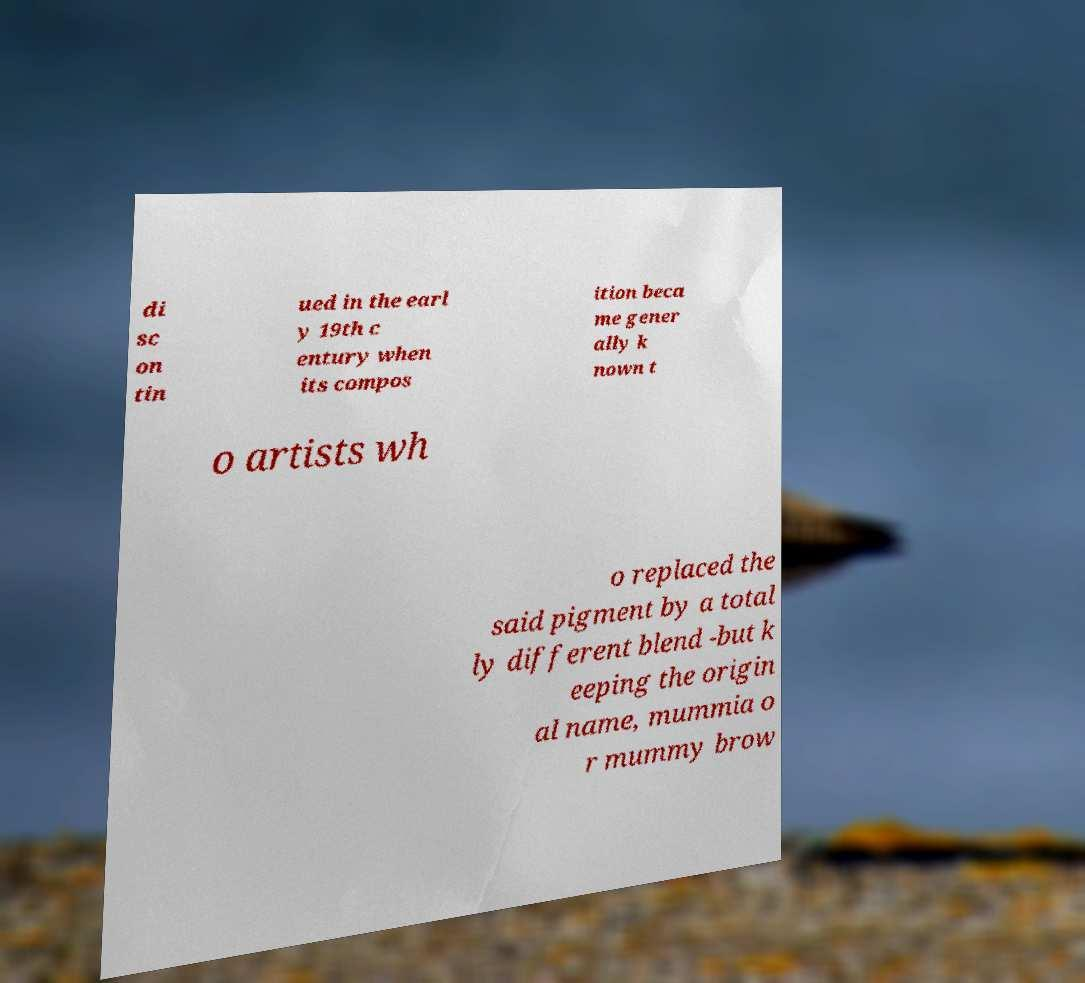For documentation purposes, I need the text within this image transcribed. Could you provide that? di sc on tin ued in the earl y 19th c entury when its compos ition beca me gener ally k nown t o artists wh o replaced the said pigment by a total ly different blend -but k eeping the origin al name, mummia o r mummy brow 